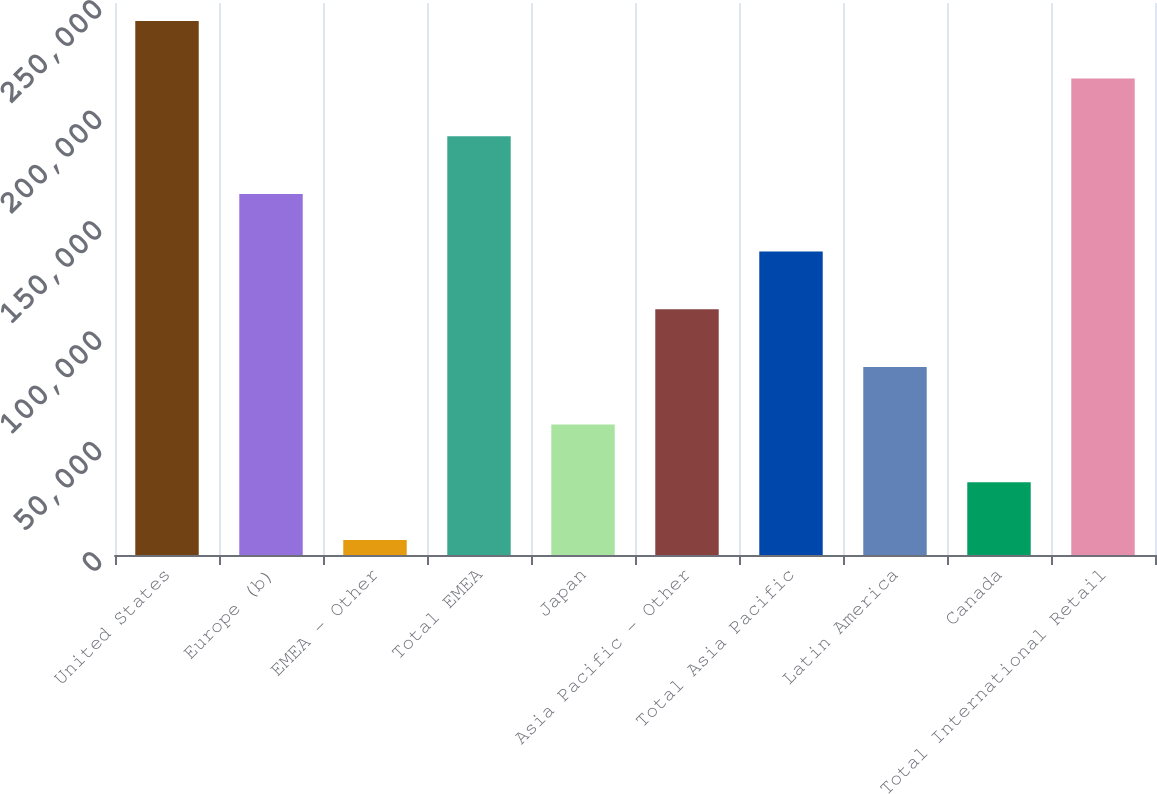<chart> <loc_0><loc_0><loc_500><loc_500><bar_chart><fcel>United States<fcel>Europe (b)<fcel>EMEA - Other<fcel>Total EMEA<fcel>Japan<fcel>Asia Pacific - Other<fcel>Total Asia Pacific<fcel>Latin America<fcel>Canada<fcel>Total International Retail<nl><fcel>241882<fcel>163532<fcel>6832<fcel>189649<fcel>59065.4<fcel>111299<fcel>137416<fcel>85182.1<fcel>32948.7<fcel>215766<nl></chart> 